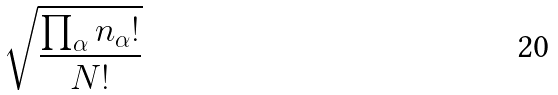Convert formula to latex. <formula><loc_0><loc_0><loc_500><loc_500>\sqrt { \frac { \prod _ { \alpha } n _ { \alpha } ! } { N ! } }</formula> 